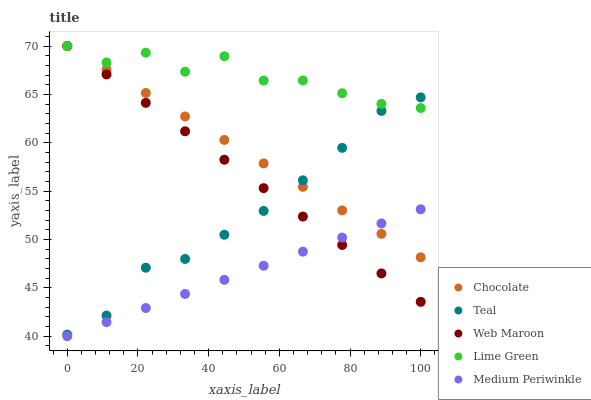Does Medium Periwinkle have the minimum area under the curve?
Answer yes or no. Yes. Does Lime Green have the maximum area under the curve?
Answer yes or no. Yes. Does Web Maroon have the minimum area under the curve?
Answer yes or no. No. Does Web Maroon have the maximum area under the curve?
Answer yes or no. No. Is Medium Periwinkle the smoothest?
Answer yes or no. Yes. Is Lime Green the roughest?
Answer yes or no. Yes. Is Web Maroon the smoothest?
Answer yes or no. No. Is Web Maroon the roughest?
Answer yes or no. No. Does Medium Periwinkle have the lowest value?
Answer yes or no. Yes. Does Web Maroon have the lowest value?
Answer yes or no. No. Does Chocolate have the highest value?
Answer yes or no. Yes. Does Medium Periwinkle have the highest value?
Answer yes or no. No. Is Medium Periwinkle less than Lime Green?
Answer yes or no. Yes. Is Lime Green greater than Medium Periwinkle?
Answer yes or no. Yes. Does Web Maroon intersect Medium Periwinkle?
Answer yes or no. Yes. Is Web Maroon less than Medium Periwinkle?
Answer yes or no. No. Is Web Maroon greater than Medium Periwinkle?
Answer yes or no. No. Does Medium Periwinkle intersect Lime Green?
Answer yes or no. No. 